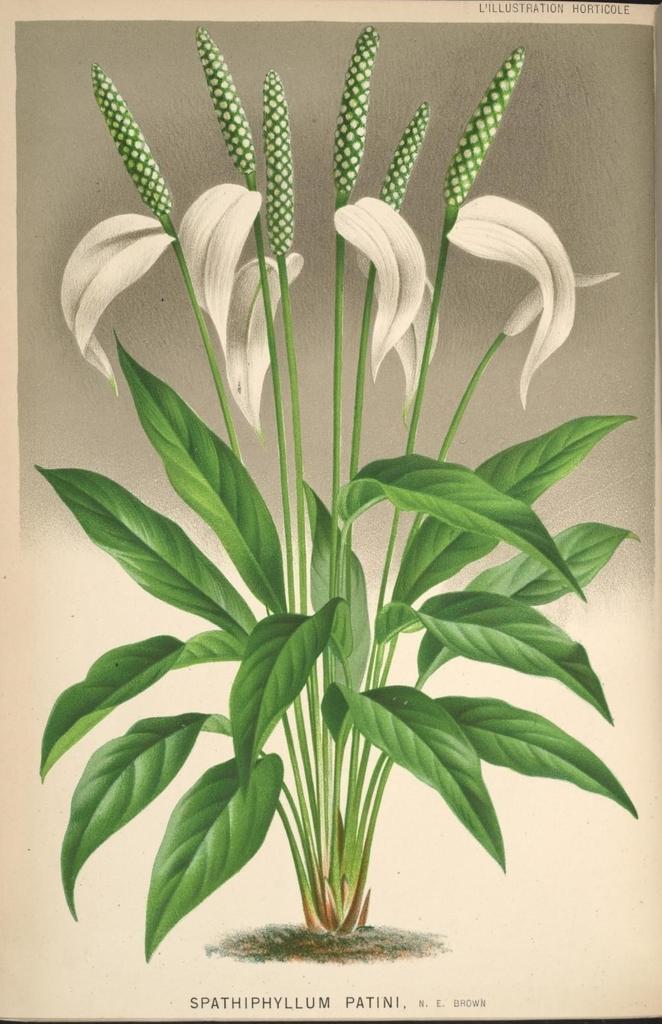Can you describe this image briefly? In this image we can see a poster of a plant with flowers and buds. 